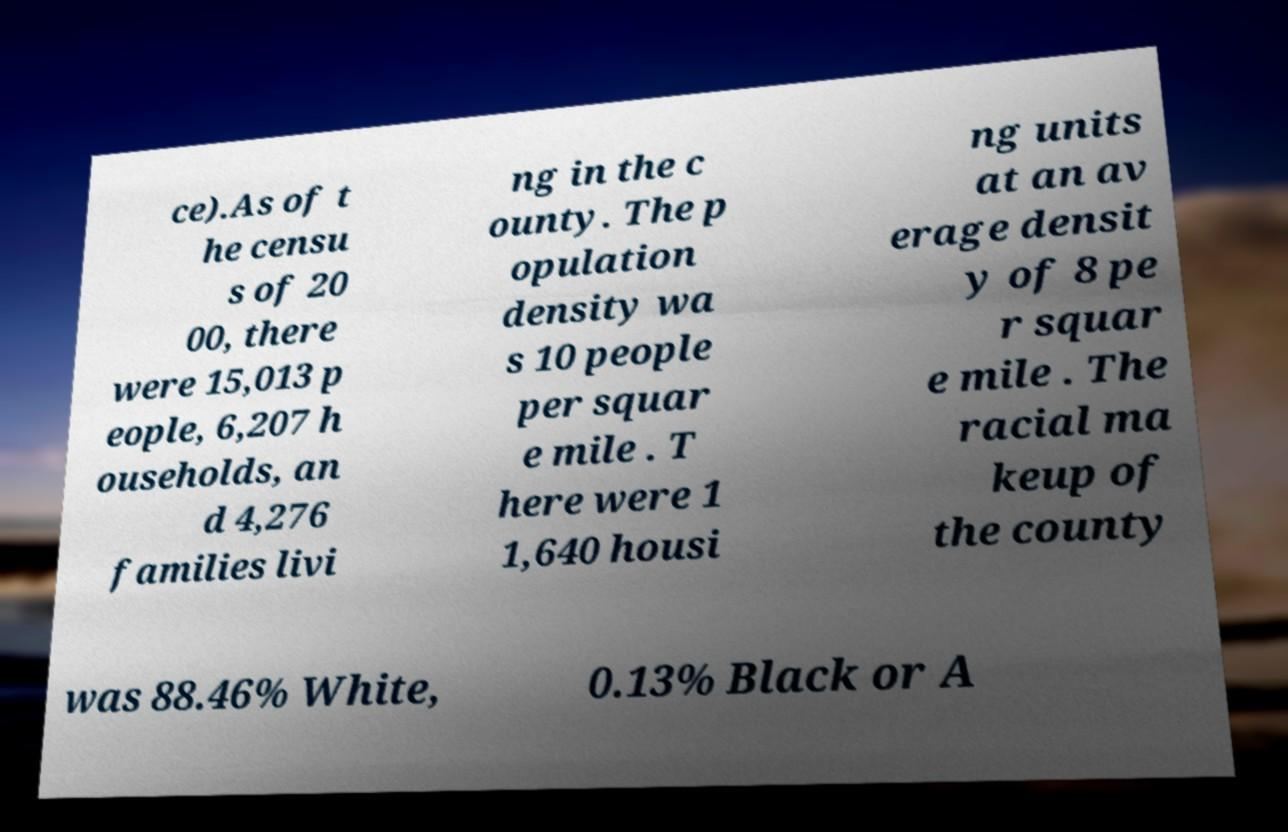What messages or text are displayed in this image? I need them in a readable, typed format. ce).As of t he censu s of 20 00, there were 15,013 p eople, 6,207 h ouseholds, an d 4,276 families livi ng in the c ounty. The p opulation density wa s 10 people per squar e mile . T here were 1 1,640 housi ng units at an av erage densit y of 8 pe r squar e mile . The racial ma keup of the county was 88.46% White, 0.13% Black or A 